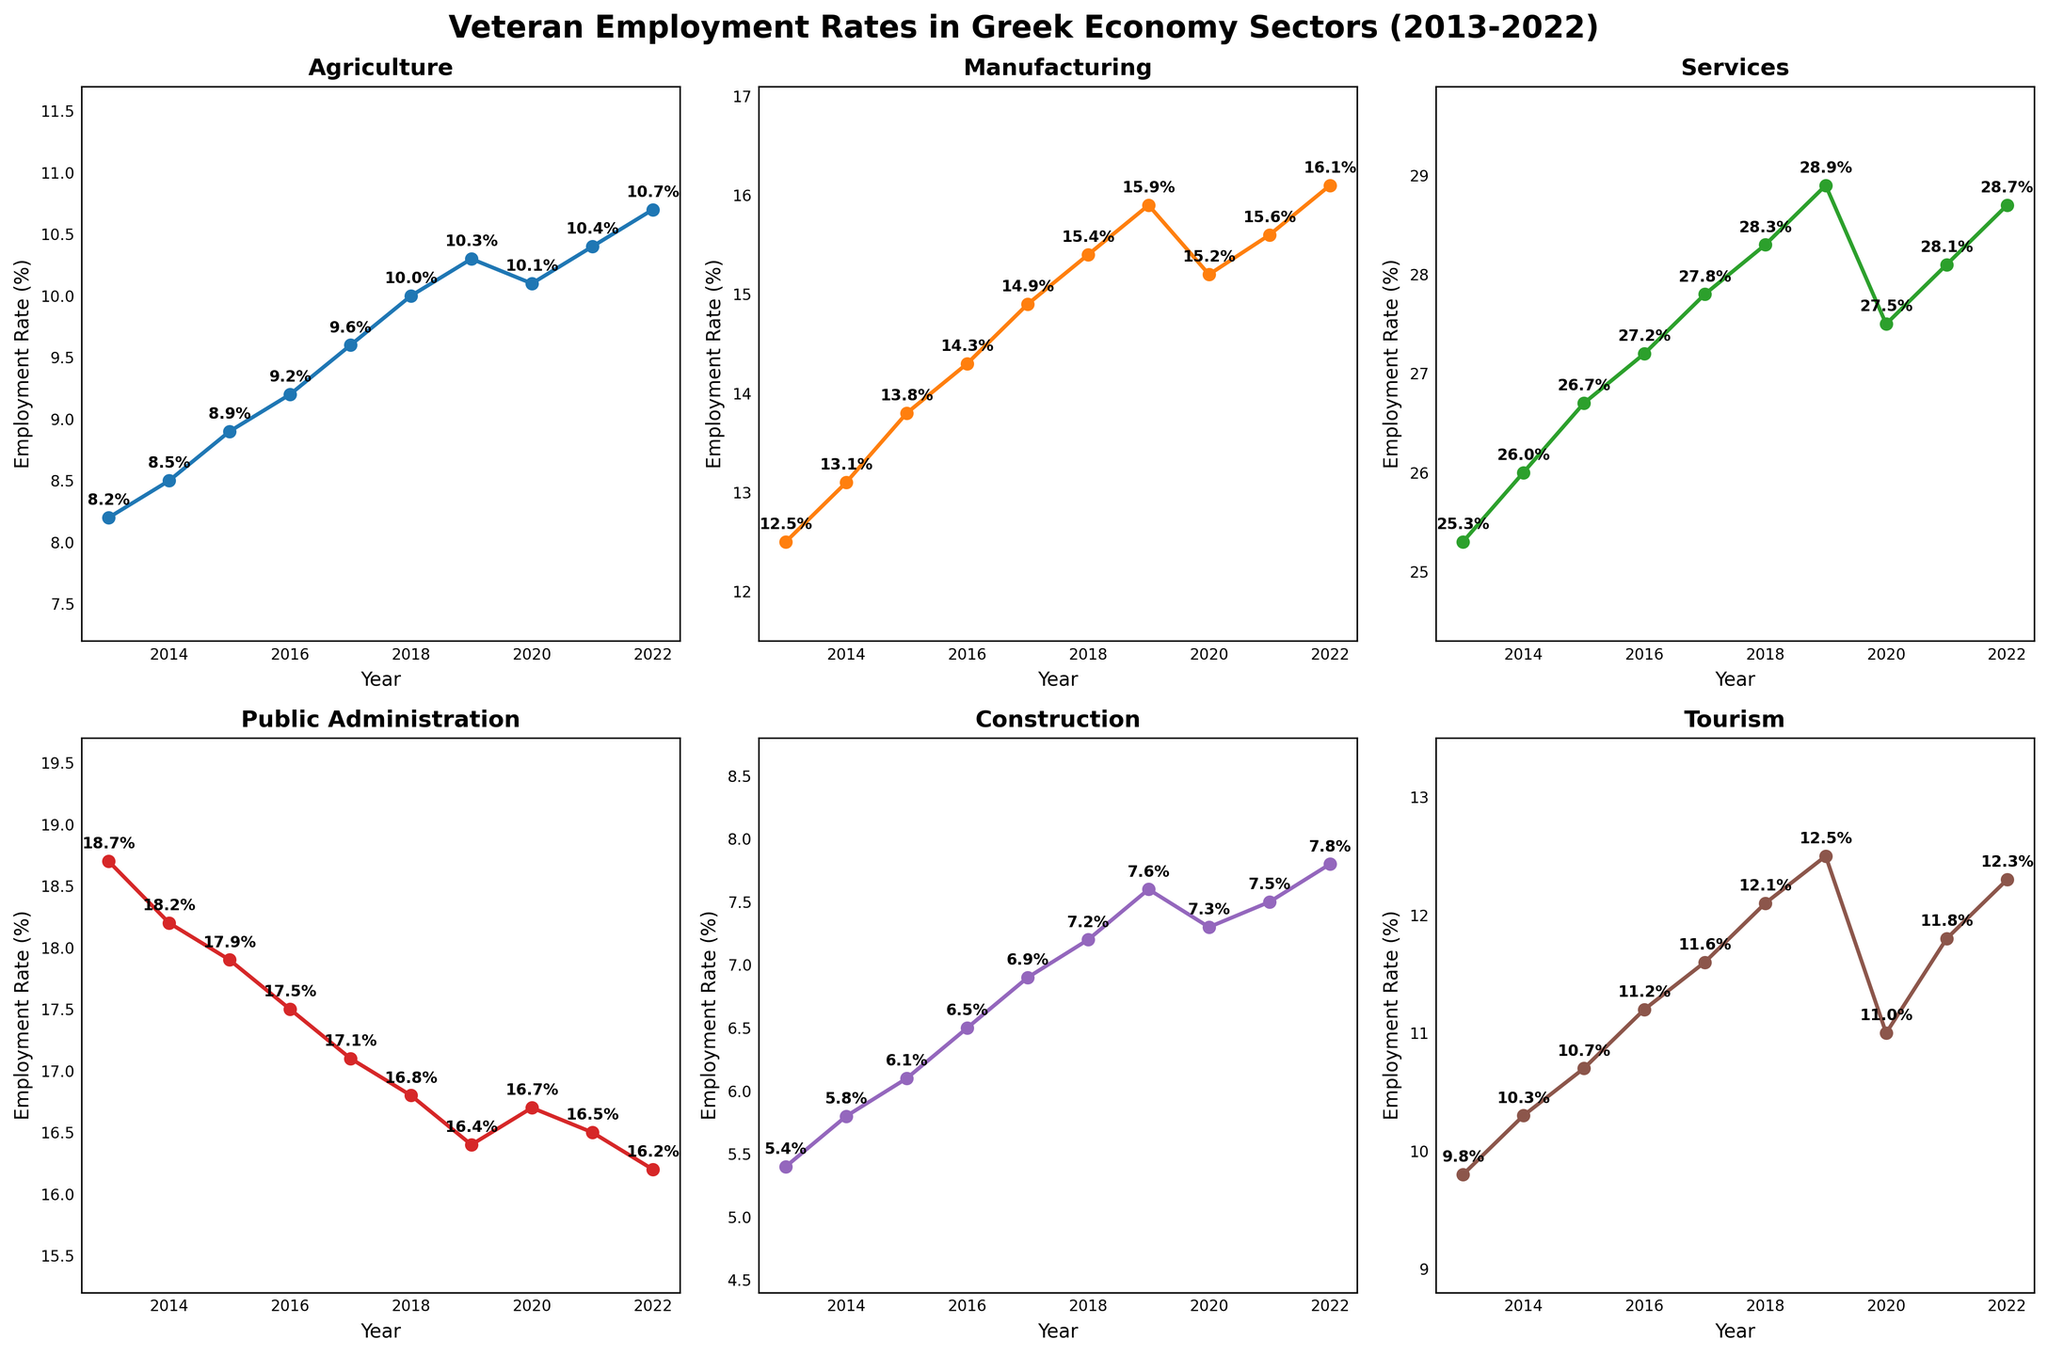What is the title of the figure? The title is at the top of the figure, and it reads "Veteran Employment Rates in Greek Economy Sectors (2013-2022)".
Answer: Veteran Employment Rates in Greek Economy Sectors (2013-2022) Which sector had the highest employment rate in 2022? Looking at the respective plots for each sector in 2022, Services has the highest employment rate.
Answer: Services How did the employment rate in Agriculture change from 2013 to 2022? The plot for Agriculture shows an increasing trend; 2013 has a rate of 8.2% and 2022 has a rate of 10.7%.
Answer: Increased by 2.5% What is the average employment rate in Manufacturing over the last decade? The values for each year are presented on the Manufacturing subplot: (12.5 + 13.1 + 13.8 + 14.3 + 14.9 + 15.4 + 15.9 + 15.2 + 15.6 + 16.1)/10 = 14.68.
Answer: 14.7% In which year did the Services sector see its highest employment rate? The highest point in the Services plot corresponds to 2022 with a value of 28.7%.
Answer: 2022 Is there a sector where the employment rate decreased from 2019 to 2020? Comparing 2019 and 2020 data points in each subplot, Services decreased from 28.9% to 27.5%.
Answer: Yes, Services By how much did the employment rate in Public Administration change from 2017 to 2022? Looking at the Public Administration subplot: 2017 has a rate of 17.1% and 2022 has a rate of 16.2%. The change is 16.2 - 17.1 = -0.9%.
Answer: Decreased by 0.9% Which sector has the most consistent (steady) employment rate over the decade? Analyzing the plots for consistent/steady trends, Public Administration shows the least variation, moving gradually from 18.7% to 16.2%.
Answer: Public Administration 